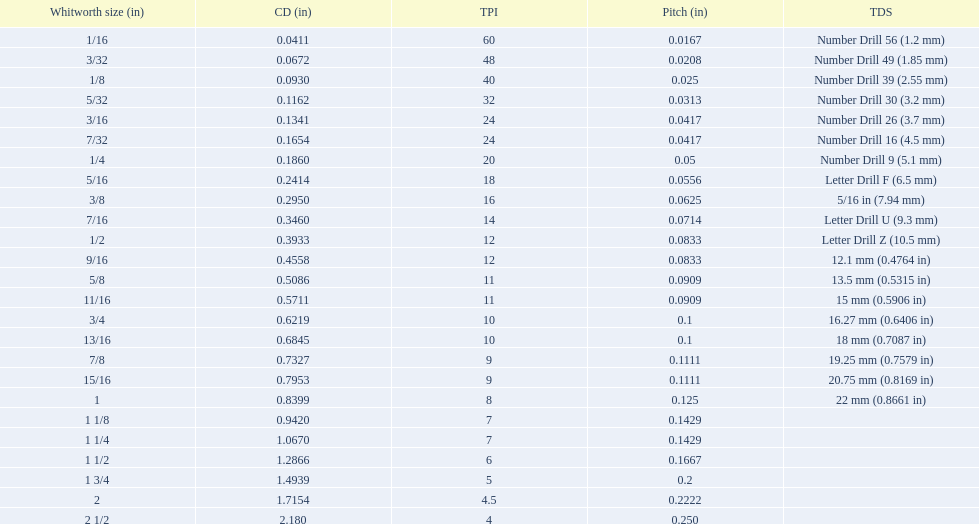What are all the whitworth sizes? 1/16, 3/32, 1/8, 5/32, 3/16, 7/32, 1/4, 5/16, 3/8, 7/16, 1/2, 9/16, 5/8, 11/16, 3/4, 13/16, 7/8, 15/16, 1, 1 1/8, 1 1/4, 1 1/2, 1 3/4, 2, 2 1/2. What are the threads per inch of these sizes? 60, 48, 40, 32, 24, 24, 20, 18, 16, 14, 12, 12, 11, 11, 10, 10, 9, 9, 8, 7, 7, 6, 5, 4.5, 4. Of these, which are 5? 5. What whitworth size has this threads per inch? 1 3/4. 